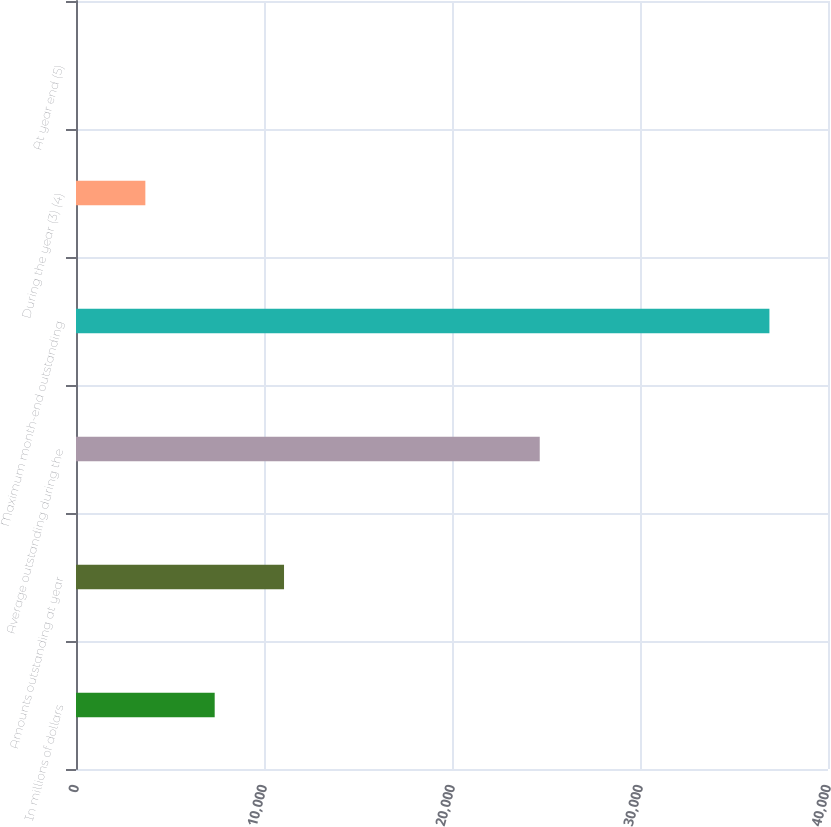Convert chart. <chart><loc_0><loc_0><loc_500><loc_500><bar_chart><fcel>In millions of dollars<fcel>Amounts outstanding at year<fcel>Average outstanding during the<fcel>Maximum month-end outstanding<fcel>During the year (3) (4)<fcel>At year end (5)<nl><fcel>7377.08<fcel>11065.5<fcel>24667<fcel>36884<fcel>3688.71<fcel>0.34<nl></chart> 